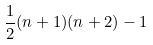Convert formula to latex. <formula><loc_0><loc_0><loc_500><loc_500>\frac { 1 } { 2 } ( n + 1 ) ( n + 2 ) - 1</formula> 